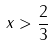<formula> <loc_0><loc_0><loc_500><loc_500>x > \frac { 2 } { 3 }</formula> 